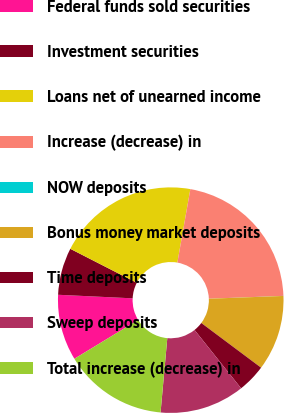<chart> <loc_0><loc_0><loc_500><loc_500><pie_chart><fcel>Federal funds sold securities<fcel>Investment securities<fcel>Loans net of unearned income<fcel>Increase (decrease) in<fcel>NOW deposits<fcel>Bonus money market deposits<fcel>Time deposits<fcel>Sweep deposits<fcel>Total increase (decrease) in<nl><fcel>9.46%<fcel>6.76%<fcel>20.26%<fcel>21.61%<fcel>0.01%<fcel>10.81%<fcel>4.06%<fcel>12.16%<fcel>14.86%<nl></chart> 